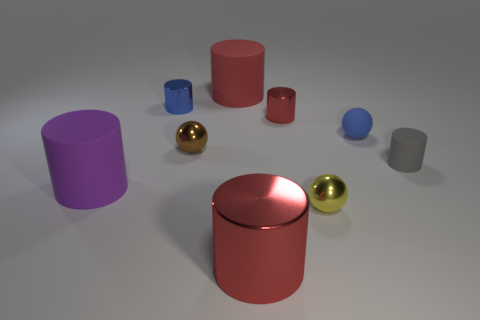What color is the big object on the left side of the blue object that is left of the tiny yellow object?
Offer a very short reply. Purple. Do the tiny matte cylinder and the metal cylinder in front of the small blue sphere have the same color?
Ensure brevity in your answer.  No. There is a big matte cylinder that is in front of the cylinder behind the blue cylinder; how many rubber objects are behind it?
Your answer should be very brief. 3. Are there any blue balls in front of the small red cylinder?
Your answer should be very brief. Yes. Is there any other thing that is the same color as the big metal cylinder?
Offer a very short reply. Yes. What number of spheres are either red objects or small yellow objects?
Offer a terse response. 1. What number of big cylinders are both in front of the large red matte object and right of the small blue metallic cylinder?
Keep it short and to the point. 1. Is the number of small red metal things that are on the right side of the tiny gray thing the same as the number of tiny matte spheres behind the small blue matte thing?
Offer a very short reply. Yes. There is a big red object in front of the purple matte object; is it the same shape as the blue rubber object?
Offer a very short reply. No. What shape is the large rubber thing that is in front of the metal cylinder on the right side of the large red cylinder in front of the blue matte object?
Provide a short and direct response. Cylinder. 